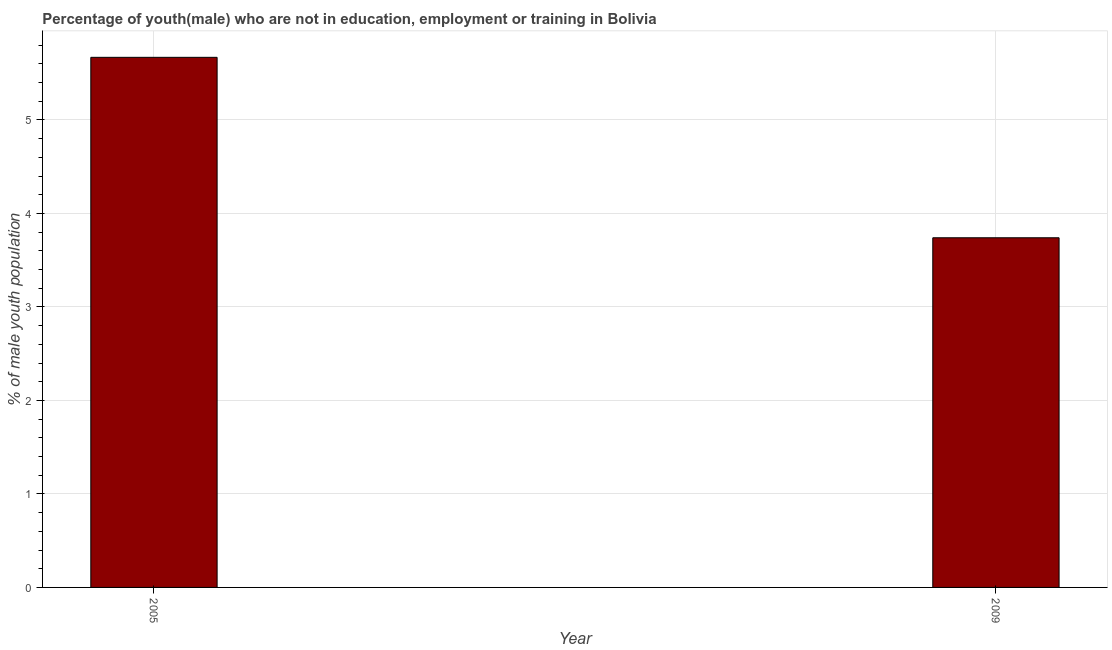What is the title of the graph?
Your answer should be compact. Percentage of youth(male) who are not in education, employment or training in Bolivia. What is the label or title of the Y-axis?
Give a very brief answer. % of male youth population. What is the unemployed male youth population in 2005?
Provide a short and direct response. 5.67. Across all years, what is the maximum unemployed male youth population?
Give a very brief answer. 5.67. Across all years, what is the minimum unemployed male youth population?
Offer a terse response. 3.74. What is the sum of the unemployed male youth population?
Offer a terse response. 9.41. What is the difference between the unemployed male youth population in 2005 and 2009?
Offer a very short reply. 1.93. What is the average unemployed male youth population per year?
Your answer should be very brief. 4.71. What is the median unemployed male youth population?
Your answer should be compact. 4.71. Do a majority of the years between 2009 and 2005 (inclusive) have unemployed male youth population greater than 5.2 %?
Offer a very short reply. No. What is the ratio of the unemployed male youth population in 2005 to that in 2009?
Give a very brief answer. 1.52. Is the unemployed male youth population in 2005 less than that in 2009?
Ensure brevity in your answer.  No. In how many years, is the unemployed male youth population greater than the average unemployed male youth population taken over all years?
Your response must be concise. 1. Are all the bars in the graph horizontal?
Your answer should be compact. No. How many years are there in the graph?
Offer a very short reply. 2. What is the difference between two consecutive major ticks on the Y-axis?
Provide a succinct answer. 1. What is the % of male youth population in 2005?
Offer a terse response. 5.67. What is the % of male youth population of 2009?
Offer a very short reply. 3.74. What is the difference between the % of male youth population in 2005 and 2009?
Offer a very short reply. 1.93. What is the ratio of the % of male youth population in 2005 to that in 2009?
Provide a succinct answer. 1.52. 